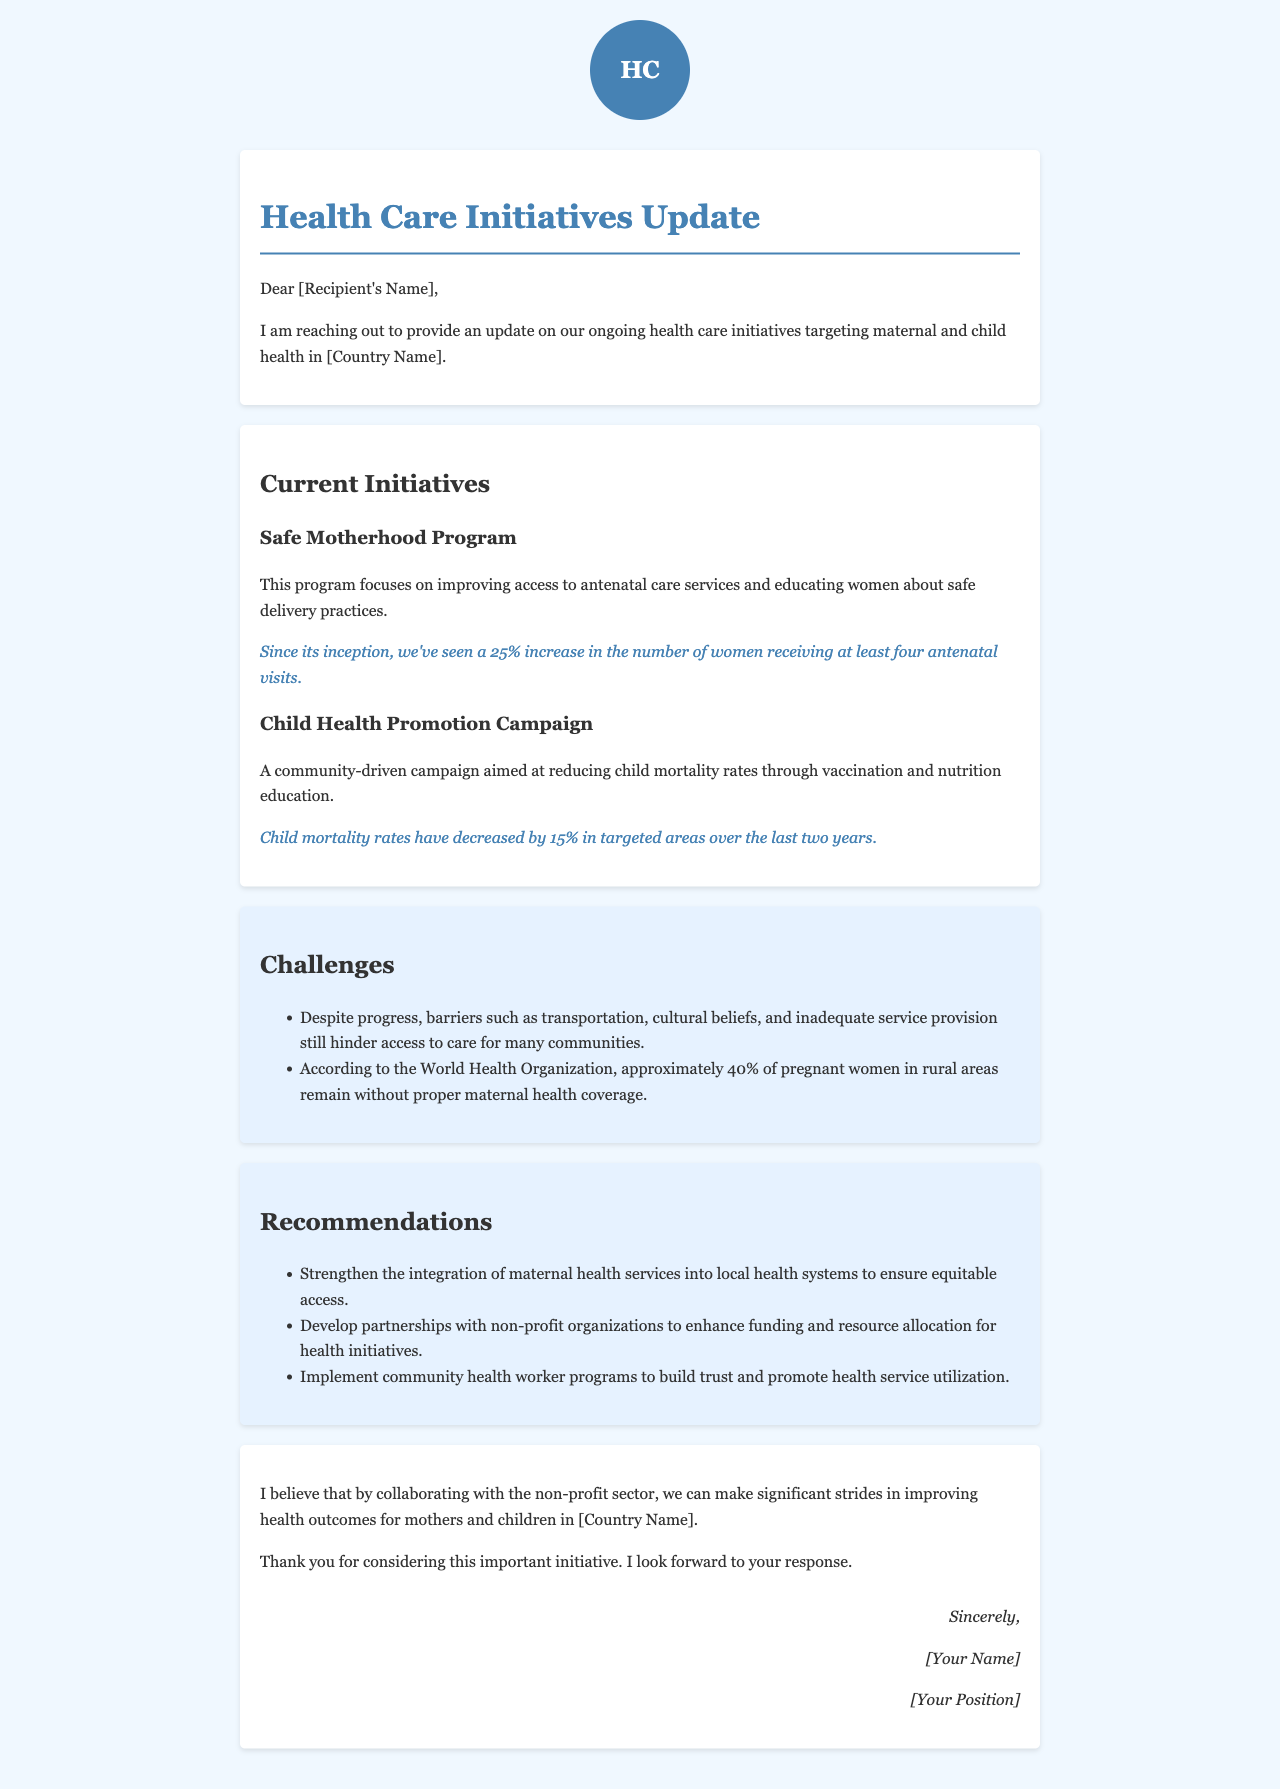What is the percentage increase in antenatal visits? The document states that there is a 25% increase in the number of women receiving at least four antenatal visits.
Answer: 25% What is the focus of the Safe Motherhood Program? The Safe Motherhood Program focuses on improving access to antenatal care services and educating women about safe delivery practices.
Answer: Antenatal care and safe delivery education What is the decrease in child mortality rates over the last two years? According to the document, child mortality rates have decreased by 15% in targeted areas over the last two years.
Answer: 15% What are some barriers to access to maternal health care mentioned? The document lists transportation, cultural beliefs, and inadequate service provision as barriers to access.
Answer: Transportation, cultural beliefs, inadequate service provision What percentage of pregnant women in rural areas lack proper maternal health coverage? The document cites that approximately 40% of pregnant women in rural areas remain without proper maternal health coverage.
Answer: 40% What is one recommendation for improving maternal health services? The document recommends strengthening the integration of maternal health services into local health systems.
Answer: Strengthen integration of maternal health services What initiative is aimed at reducing child mortality rates? The Child Health Promotion Campaign is aimed at reducing child mortality rates.
Answer: Child Health Promotion Campaign Who is the intended audience for this letter? The letter is directed towards an unspecified recipient, likely a collaborator or stakeholder in health initiatives.
Answer: [Recipient's Name] 